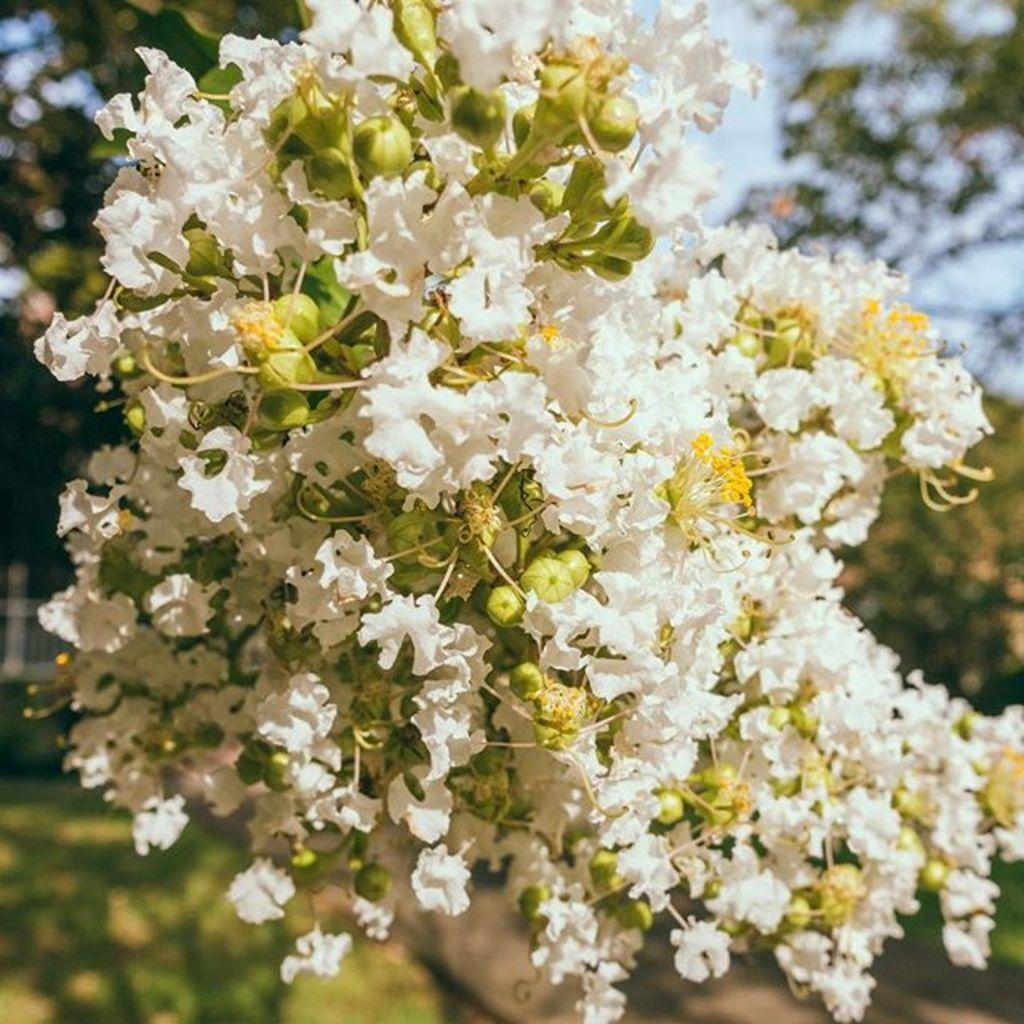What type of tree is present in the image? There is a tree with white flowers in the image. What else can be seen in the background of the image? There are plants in the background of the image. What color is the sky in the image? The sky is blue in the image. Is there a war happening in the image? No, there is no indication of a war or any conflict in the image. The image features a tree with white flowers, plants in the background, and a blue sky. 